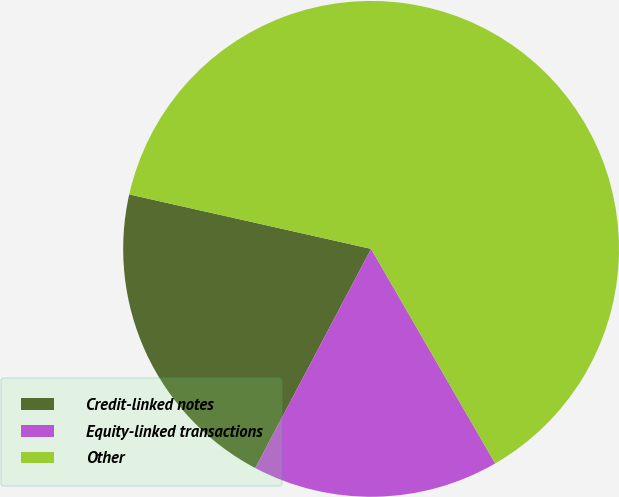Convert chart to OTSL. <chart><loc_0><loc_0><loc_500><loc_500><pie_chart><fcel>Credit-linked notes<fcel>Equity-linked transactions<fcel>Other<nl><fcel>20.79%<fcel>16.08%<fcel>63.13%<nl></chart> 